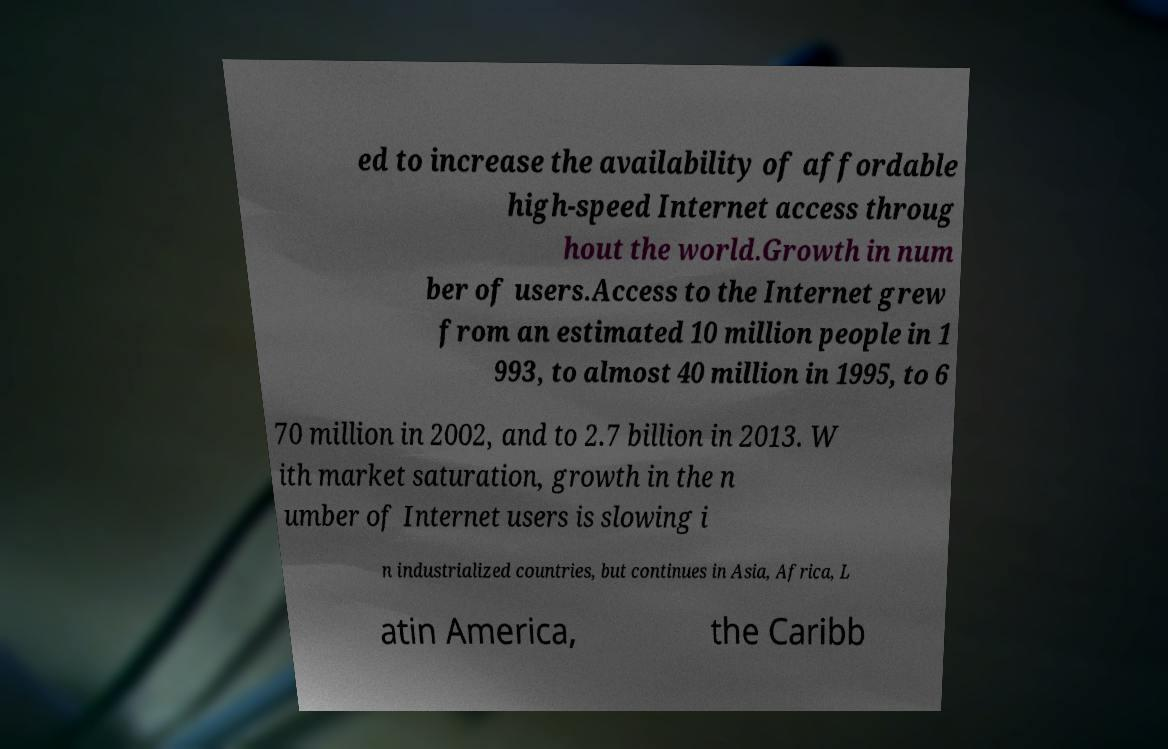Can you accurately transcribe the text from the provided image for me? ed to increase the availability of affordable high-speed Internet access throug hout the world.Growth in num ber of users.Access to the Internet grew from an estimated 10 million people in 1 993, to almost 40 million in 1995, to 6 70 million in 2002, and to 2.7 billion in 2013. W ith market saturation, growth in the n umber of Internet users is slowing i n industrialized countries, but continues in Asia, Africa, L atin America, the Caribb 